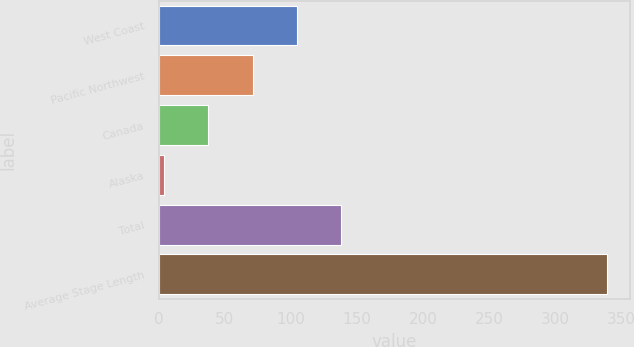<chart> <loc_0><loc_0><loc_500><loc_500><bar_chart><fcel>West Coast<fcel>Pacific Northwest<fcel>Canada<fcel>Alaska<fcel>Total<fcel>Average Stage Length<nl><fcel>104.5<fcel>71<fcel>37.5<fcel>4<fcel>138<fcel>339<nl></chart> 